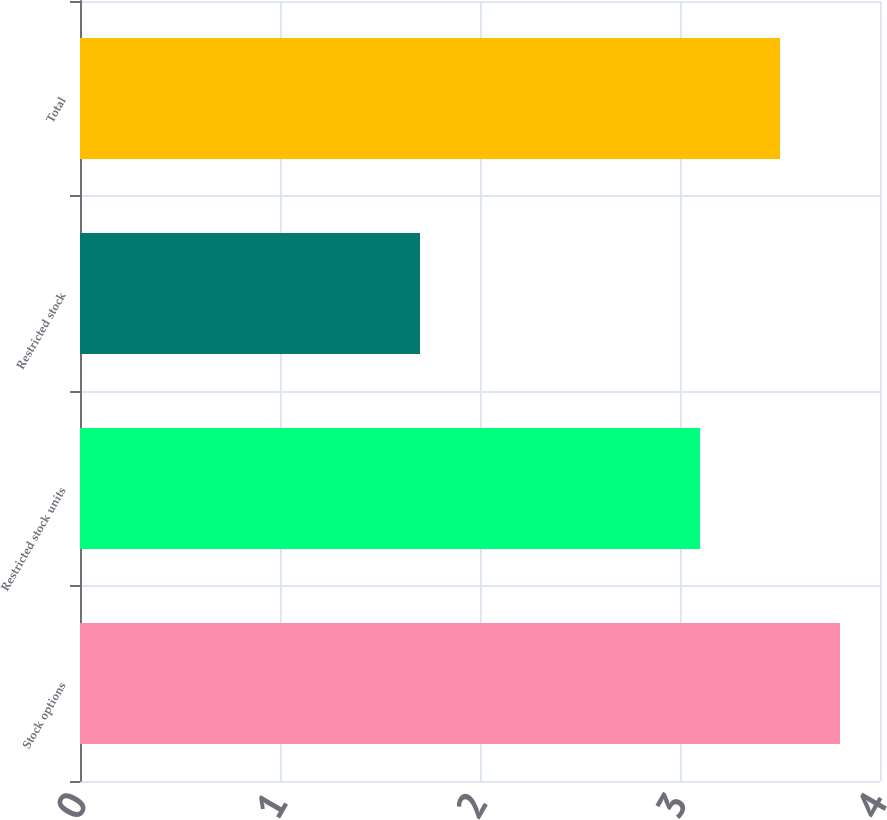<chart> <loc_0><loc_0><loc_500><loc_500><bar_chart><fcel>Stock options<fcel>Restricted stock units<fcel>Restricted stock<fcel>Total<nl><fcel>3.8<fcel>3.1<fcel>1.7<fcel>3.5<nl></chart> 